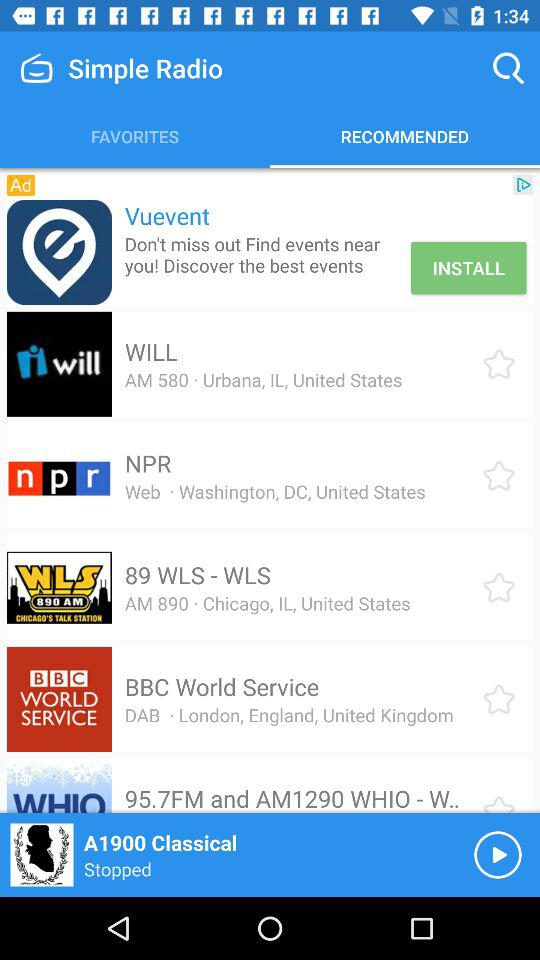Which tab is selected? The selected tab is "RECOMMENDED". 